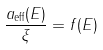<formula> <loc_0><loc_0><loc_500><loc_500>\frac { a _ { \text {eff} } ( E ) } { \xi } = f ( E )</formula> 